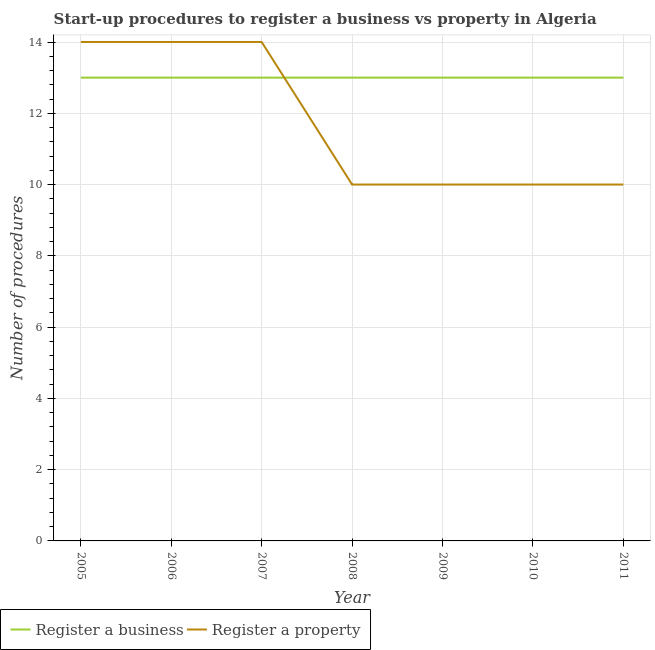What is the number of procedures to register a property in 2007?
Your answer should be very brief. 14. Across all years, what is the maximum number of procedures to register a business?
Offer a terse response. 13. Across all years, what is the minimum number of procedures to register a business?
Your answer should be very brief. 13. In which year was the number of procedures to register a property minimum?
Keep it short and to the point. 2008. What is the total number of procedures to register a business in the graph?
Offer a very short reply. 91. What is the difference between the number of procedures to register a business in 2007 and that in 2011?
Make the answer very short. 0. What is the difference between the number of procedures to register a property in 2007 and the number of procedures to register a business in 2010?
Provide a short and direct response. 1. In the year 2009, what is the difference between the number of procedures to register a property and number of procedures to register a business?
Make the answer very short. -3. In how many years, is the number of procedures to register a business greater than 6.4?
Your answer should be compact. 7. What is the ratio of the number of procedures to register a business in 2006 to that in 2008?
Your answer should be compact. 1. Is the number of procedures to register a business in 2009 less than that in 2011?
Provide a succinct answer. No. Is the difference between the number of procedures to register a property in 2008 and 2010 greater than the difference between the number of procedures to register a business in 2008 and 2010?
Give a very brief answer. No. What is the difference between the highest and the lowest number of procedures to register a property?
Ensure brevity in your answer.  4. In how many years, is the number of procedures to register a property greater than the average number of procedures to register a property taken over all years?
Your answer should be very brief. 3. Is the sum of the number of procedures to register a property in 2007 and 2010 greater than the maximum number of procedures to register a business across all years?
Provide a short and direct response. Yes. Is the number of procedures to register a business strictly greater than the number of procedures to register a property over the years?
Offer a terse response. No. Is the number of procedures to register a property strictly less than the number of procedures to register a business over the years?
Ensure brevity in your answer.  No. How many lines are there?
Your answer should be compact. 2. What is the difference between two consecutive major ticks on the Y-axis?
Ensure brevity in your answer.  2. Does the graph contain any zero values?
Give a very brief answer. No. Where does the legend appear in the graph?
Keep it short and to the point. Bottom left. How many legend labels are there?
Your response must be concise. 2. How are the legend labels stacked?
Make the answer very short. Horizontal. What is the title of the graph?
Offer a very short reply. Start-up procedures to register a business vs property in Algeria. Does "Female labourers" appear as one of the legend labels in the graph?
Provide a short and direct response. No. What is the label or title of the Y-axis?
Offer a terse response. Number of procedures. What is the Number of procedures of Register a business in 2005?
Your answer should be very brief. 13. What is the Number of procedures in Register a business in 2006?
Keep it short and to the point. 13. What is the Number of procedures of Register a business in 2008?
Offer a terse response. 13. What is the Number of procedures in Register a property in 2008?
Offer a terse response. 10. What is the Number of procedures of Register a business in 2009?
Offer a very short reply. 13. What is the Number of procedures in Register a business in 2011?
Offer a terse response. 13. Across all years, what is the maximum Number of procedures of Register a business?
Provide a short and direct response. 13. Across all years, what is the minimum Number of procedures of Register a business?
Give a very brief answer. 13. What is the total Number of procedures of Register a business in the graph?
Provide a succinct answer. 91. What is the total Number of procedures of Register a property in the graph?
Your response must be concise. 82. What is the difference between the Number of procedures of Register a property in 2005 and that in 2006?
Your answer should be very brief. 0. What is the difference between the Number of procedures in Register a property in 2005 and that in 2007?
Offer a very short reply. 0. What is the difference between the Number of procedures in Register a property in 2005 and that in 2009?
Offer a very short reply. 4. What is the difference between the Number of procedures of Register a property in 2005 and that in 2011?
Keep it short and to the point. 4. What is the difference between the Number of procedures of Register a business in 2006 and that in 2007?
Your answer should be very brief. 0. What is the difference between the Number of procedures of Register a property in 2006 and that in 2007?
Your answer should be very brief. 0. What is the difference between the Number of procedures in Register a business in 2006 and that in 2010?
Provide a short and direct response. 0. What is the difference between the Number of procedures of Register a property in 2006 and that in 2010?
Keep it short and to the point. 4. What is the difference between the Number of procedures of Register a business in 2006 and that in 2011?
Provide a short and direct response. 0. What is the difference between the Number of procedures of Register a property in 2007 and that in 2008?
Ensure brevity in your answer.  4. What is the difference between the Number of procedures of Register a business in 2007 and that in 2009?
Offer a terse response. 0. What is the difference between the Number of procedures in Register a business in 2007 and that in 2010?
Your answer should be compact. 0. What is the difference between the Number of procedures in Register a property in 2007 and that in 2010?
Provide a short and direct response. 4. What is the difference between the Number of procedures of Register a business in 2008 and that in 2009?
Your answer should be very brief. 0. What is the difference between the Number of procedures in Register a property in 2008 and that in 2009?
Provide a short and direct response. 0. What is the difference between the Number of procedures in Register a business in 2008 and that in 2010?
Provide a succinct answer. 0. What is the difference between the Number of procedures in Register a property in 2008 and that in 2010?
Offer a very short reply. 0. What is the difference between the Number of procedures in Register a business in 2008 and that in 2011?
Offer a terse response. 0. What is the difference between the Number of procedures of Register a property in 2009 and that in 2010?
Your answer should be compact. 0. What is the difference between the Number of procedures in Register a business in 2009 and that in 2011?
Your response must be concise. 0. What is the difference between the Number of procedures of Register a business in 2005 and the Number of procedures of Register a property in 2007?
Your answer should be compact. -1. What is the difference between the Number of procedures of Register a business in 2005 and the Number of procedures of Register a property in 2008?
Offer a terse response. 3. What is the difference between the Number of procedures of Register a business in 2006 and the Number of procedures of Register a property in 2008?
Offer a very short reply. 3. What is the difference between the Number of procedures of Register a business in 2006 and the Number of procedures of Register a property in 2009?
Offer a very short reply. 3. What is the difference between the Number of procedures of Register a business in 2006 and the Number of procedures of Register a property in 2010?
Your answer should be compact. 3. What is the difference between the Number of procedures in Register a business in 2007 and the Number of procedures in Register a property in 2009?
Your response must be concise. 3. What is the difference between the Number of procedures in Register a business in 2008 and the Number of procedures in Register a property in 2010?
Your answer should be compact. 3. What is the average Number of procedures of Register a business per year?
Make the answer very short. 13. What is the average Number of procedures in Register a property per year?
Your answer should be compact. 11.71. What is the ratio of the Number of procedures in Register a business in 2005 to that in 2006?
Offer a terse response. 1. What is the ratio of the Number of procedures of Register a property in 2005 to that in 2006?
Give a very brief answer. 1. What is the ratio of the Number of procedures in Register a business in 2005 to that in 2007?
Your answer should be compact. 1. What is the ratio of the Number of procedures of Register a property in 2005 to that in 2007?
Keep it short and to the point. 1. What is the ratio of the Number of procedures in Register a business in 2005 to that in 2009?
Your response must be concise. 1. What is the ratio of the Number of procedures in Register a property in 2005 to that in 2009?
Your answer should be very brief. 1.4. What is the ratio of the Number of procedures in Register a business in 2005 to that in 2010?
Ensure brevity in your answer.  1. What is the ratio of the Number of procedures of Register a business in 2005 to that in 2011?
Offer a terse response. 1. What is the ratio of the Number of procedures of Register a business in 2006 to that in 2007?
Provide a succinct answer. 1. What is the ratio of the Number of procedures of Register a business in 2006 to that in 2009?
Your answer should be compact. 1. What is the ratio of the Number of procedures of Register a business in 2006 to that in 2011?
Your answer should be very brief. 1. What is the ratio of the Number of procedures of Register a business in 2007 to that in 2008?
Your answer should be very brief. 1. What is the ratio of the Number of procedures in Register a property in 2007 to that in 2008?
Ensure brevity in your answer.  1.4. What is the ratio of the Number of procedures of Register a property in 2007 to that in 2009?
Offer a terse response. 1.4. What is the ratio of the Number of procedures of Register a property in 2008 to that in 2009?
Provide a short and direct response. 1. What is the ratio of the Number of procedures of Register a business in 2008 to that in 2010?
Keep it short and to the point. 1. What is the ratio of the Number of procedures of Register a property in 2008 to that in 2010?
Offer a terse response. 1. What is the ratio of the Number of procedures of Register a property in 2008 to that in 2011?
Offer a very short reply. 1. What is the ratio of the Number of procedures in Register a business in 2009 to that in 2010?
Your response must be concise. 1. What is the ratio of the Number of procedures in Register a business in 2010 to that in 2011?
Provide a short and direct response. 1. What is the difference between the highest and the lowest Number of procedures of Register a business?
Your response must be concise. 0. What is the difference between the highest and the lowest Number of procedures in Register a property?
Your answer should be very brief. 4. 